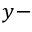Convert formula to latex. <formula><loc_0><loc_0><loc_500><loc_500>y -</formula> 